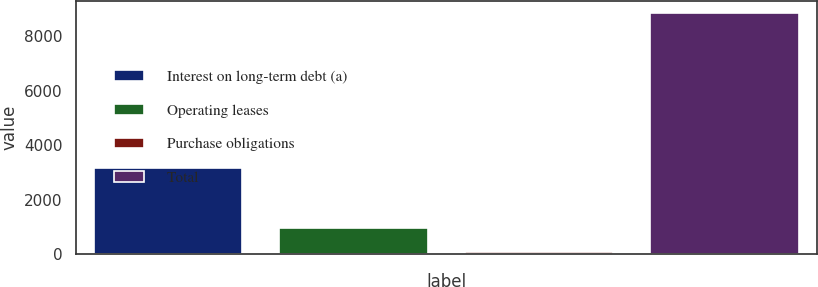<chart> <loc_0><loc_0><loc_500><loc_500><bar_chart><fcel>Interest on long-term debt (a)<fcel>Operating leases<fcel>Purchase obligations<fcel>Total<nl><fcel>3183<fcel>967.2<fcel>90<fcel>8862<nl></chart> 